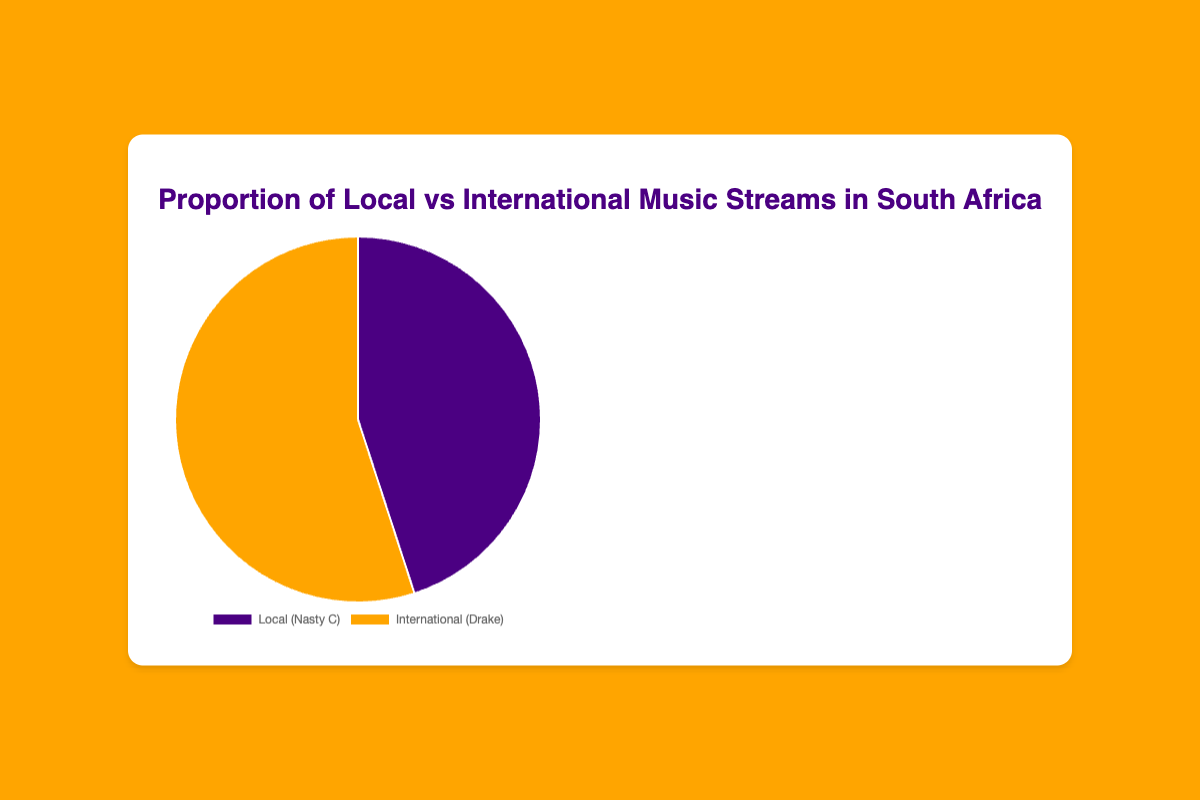What is the proportion of local music streams in South Africa? The pie chart shows the proportion of local music streams as a part of the whole, which is indicated by the section labeled 'Local (Nasty C)'. This section comprises 45% of the entire pie chart.
Answer: 45% What is the proportion of international music streams in South Africa? The pie chart shows the proportion of international music streams as a part of the whole, which is indicated by the section labeled 'International (Drake)'. This section comprises 55% of the entire pie chart.
Answer: 55% What is the difference in percentage between local and international music streams? To find the difference in percentage between local and international music streams, subtract the percentage of local streams (45%) from the percentage of international streams (55%): 55% - 45% = 10%.
Answer: 10% How does the percentage of local music streams compare to international music streams? The pie chart shows that the percentage of local music streams (45%) is less than the percentage of international music streams (55%).
Answer: Less What color represents local music streams in the pie chart? The pie chart uses different colors to represent different categories. The section labeled 'Local (Nasty C)' is colored in purple.
Answer: Purple If you combine the percentages of local and international music streams, what is the total percentage? Adding the percentage of local streams (45%) to the percentage of international streams (55%) equals 100%, as they make up the whole pie chart.
Answer: 100% Which category has a higher percentage of music streams, local or international? By observing the pie chart, the international music streams category, represented by Drake, has a higher percentage (55%) compared to the local music streams category (45%).
Answer: International What is the combined contribution of Nasty C and Drake to the total music streams in South Africa? Both Nasty C and Drake together represent the total music streams in South Africa. Nasty C accounts for 45%, and Drake for 55%, summing up to 100%.
Answer: 100% By how much would the local music streams percentage need to increase to equal the international streams percentage? The local music streams are at 45%, and international streams are at 55%. To equalize, the local streams would need to increase by the difference: 55% - 45% = 10%.
Answer: 10% What proportion of the pie chart does the combined local and international music streams exclusion of the other category make? Since local and international streams together make up the whole pie chart, excluding one category leaves the other, which maintains their individual proportions of 45% and 55%, respectively.
Answer: 100% 